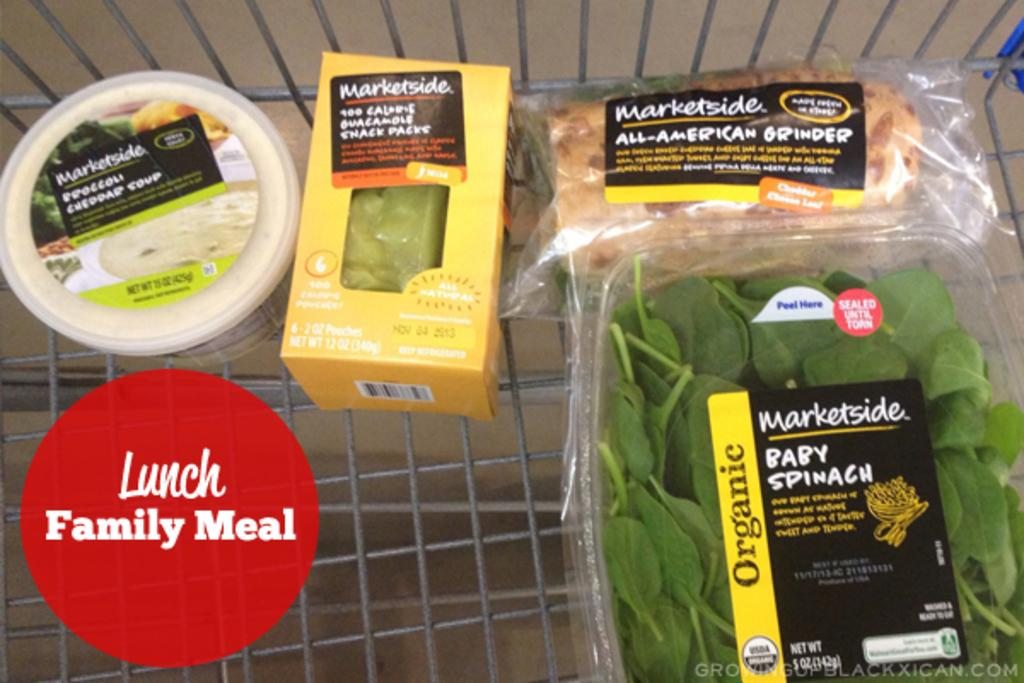What type of vegetation is present in the image? There are green leaves in the image. What can be seen in the trolley in the image? There are food items in a trolley in the image. Where is text located on the image? There is text on both the right and left sides of the image. What riddle is being solved by the person in the image? There is no person present in the image, and therefore no riddle-solving activity can be observed. What observation can be made about the text on the right side of the image? The provided facts do not include any information about the content or appearance of the text on the right side of the image, so no specific observation can be made. 